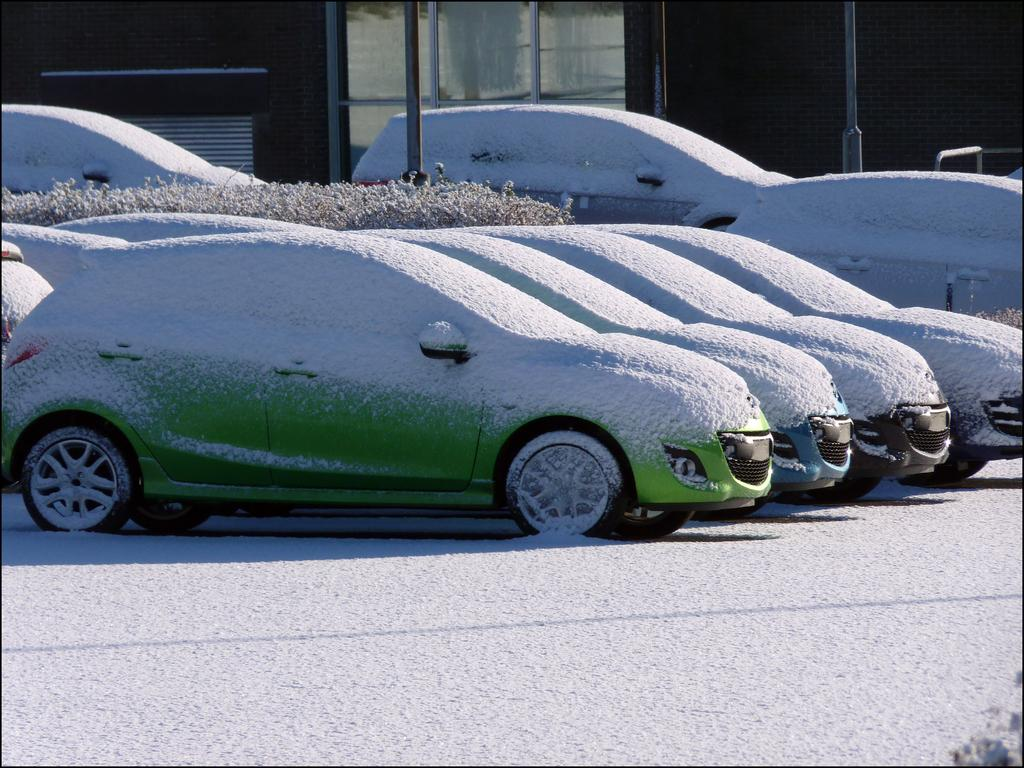What type of vehicles are visible in the image? There are cars in the image. How are the cars affected by the weather in the image? The cars are covered by snow in the image. What can be seen in the distance in the image? There is a building and poles in the background of the image. What type of nut is being taught on the floor in the image? There is no nut or teaching activity present in the image; it features cars covered by snow with a background of a building and poles. 